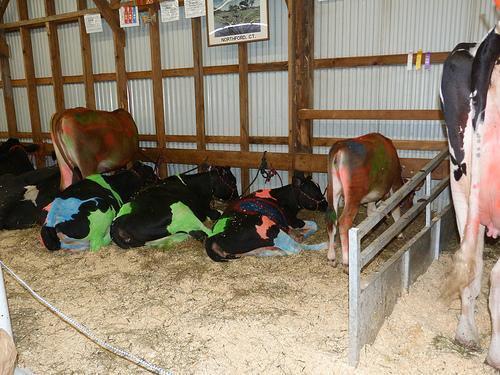How many cows are there?
Give a very brief answer. 8. How many are standing?
Give a very brief answer. 3. How many are sitting?
Give a very brief answer. 5. 